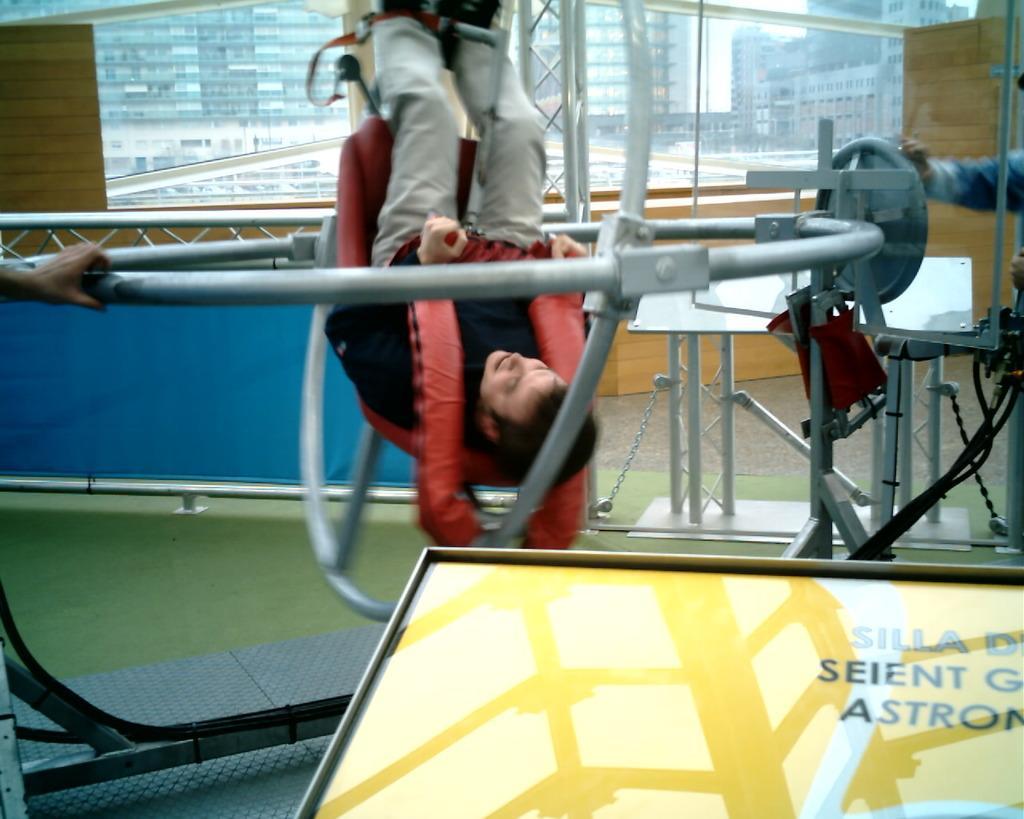Please provide a concise description of this image. In this image we can see a person standing inside a metal frame wearing dress. To the right side, we can see a person holding a wheel with his hand. In the background, we can see the window, a group of buildings and sky 